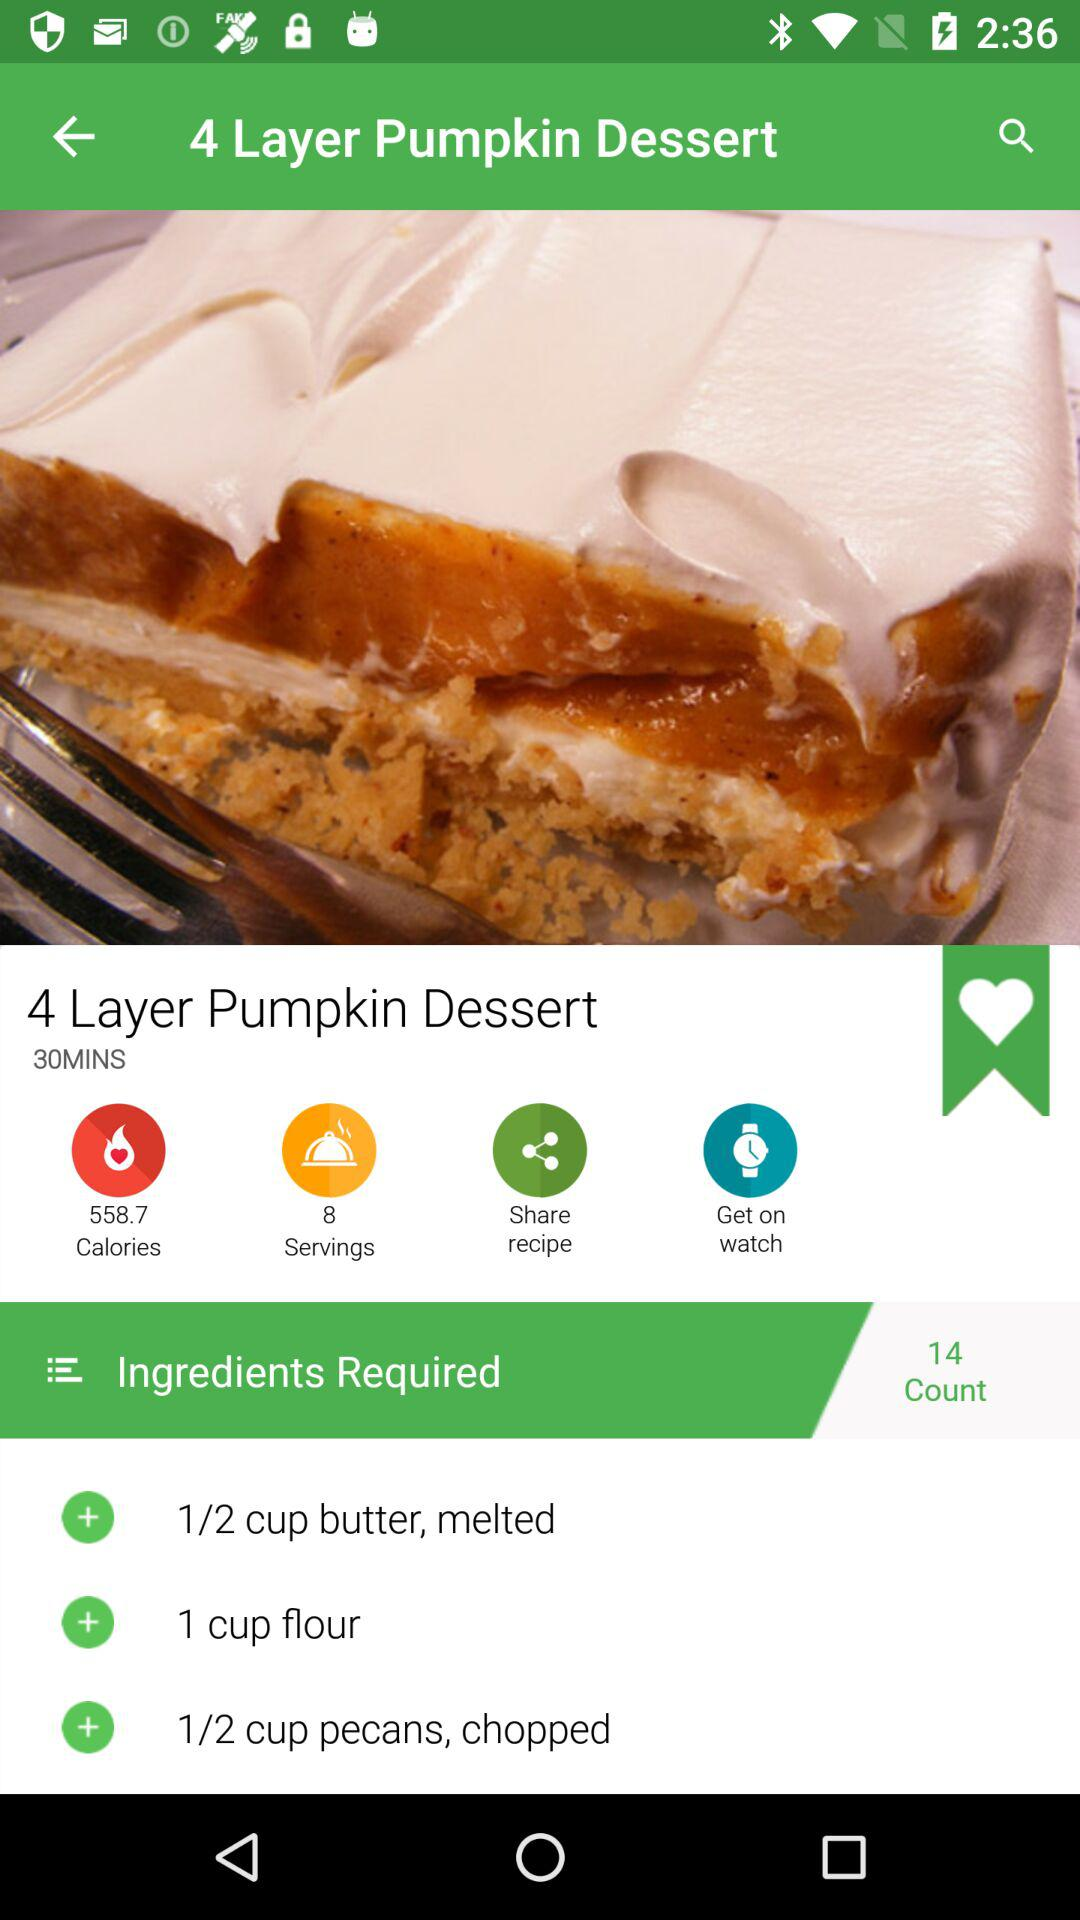How many ingredients are there in this recipe?
Answer the question using a single word or phrase. 14 